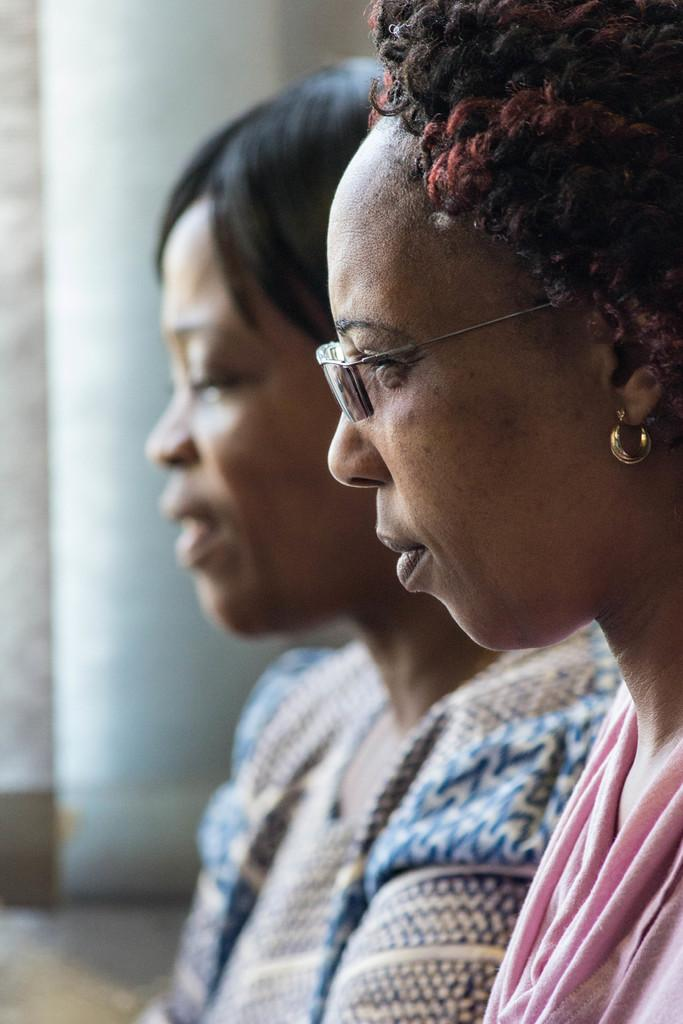How many people are in the image? There are two women in the image. Can you describe one of the women's appearance? One of the women is wearing spectacles. What can be observed about the background of the image? The background of the image is blurry. What type of mailbox can be seen in the image? There is no mailbox present in the image. What title does the woman with spectacles hold in the image? The image does not provide any information about the women's titles or roles. 